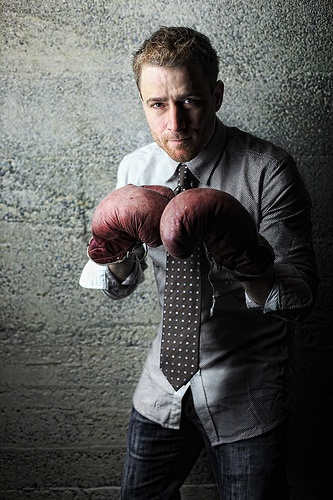Describe the objects in this image and their specific colors. I can see people in gray, black, lightgray, and darkgray tones and tie in gray, black, and darkgray tones in this image. 